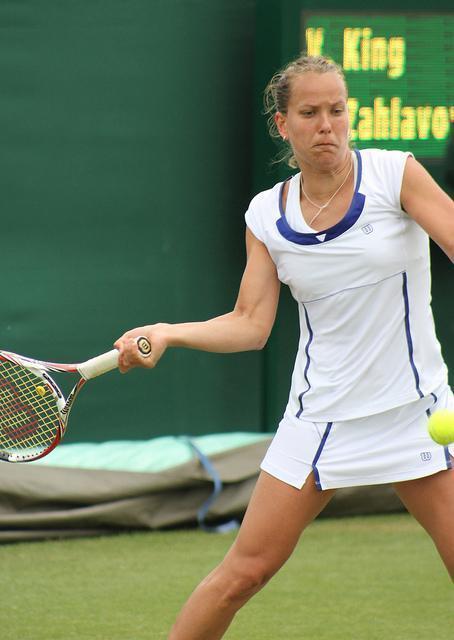What shot is this player making?
Pick the correct solution from the four options below to address the question.
Options: Serve, backhand, lob, forehand. Forehand. 